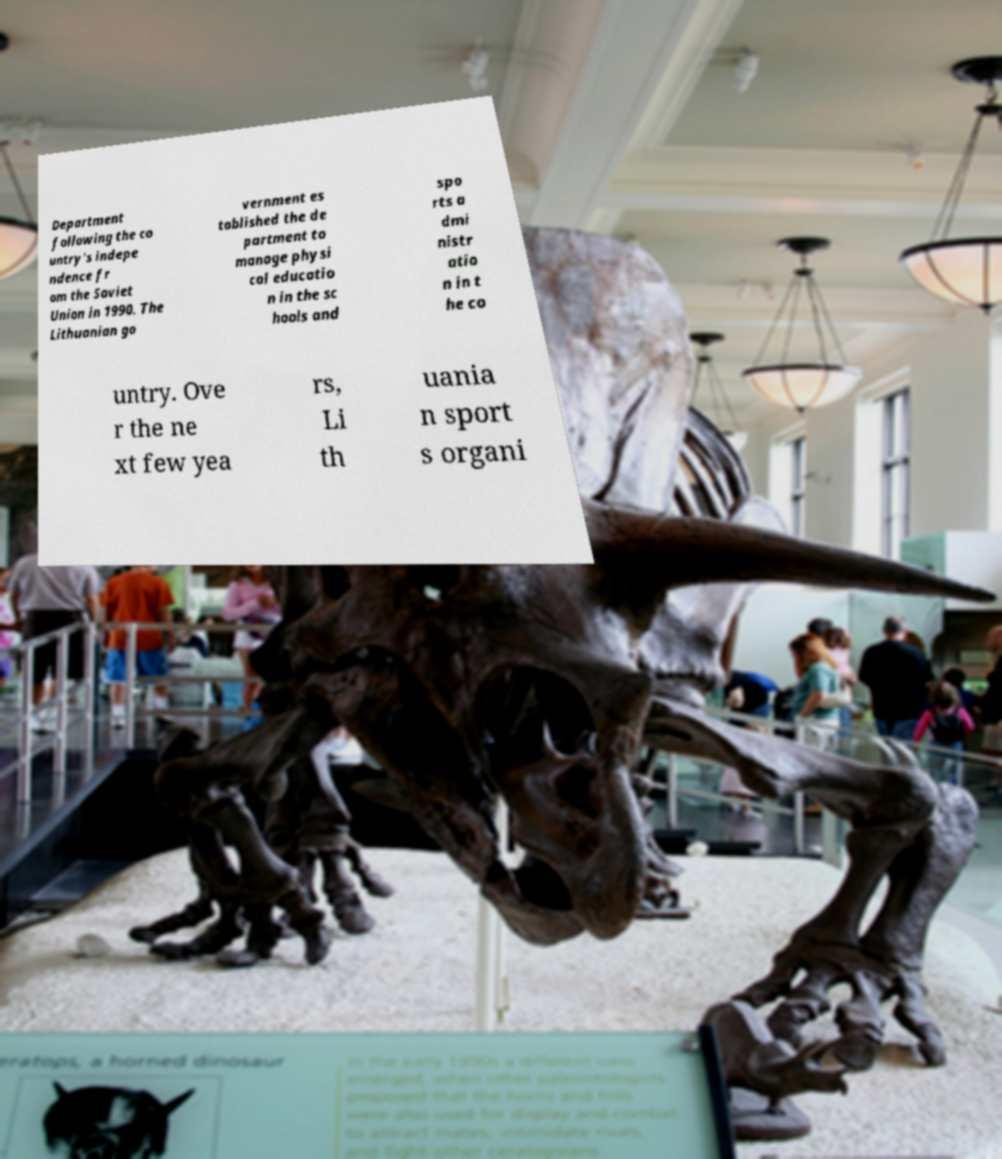What messages or text are displayed in this image? I need them in a readable, typed format. Department following the co untry's indepe ndence fr om the Soviet Union in 1990. The Lithuanian go vernment es tablished the de partment to manage physi cal educatio n in the sc hools and spo rts a dmi nistr atio n in t he co untry. Ove r the ne xt few yea rs, Li th uania n sport s organi 